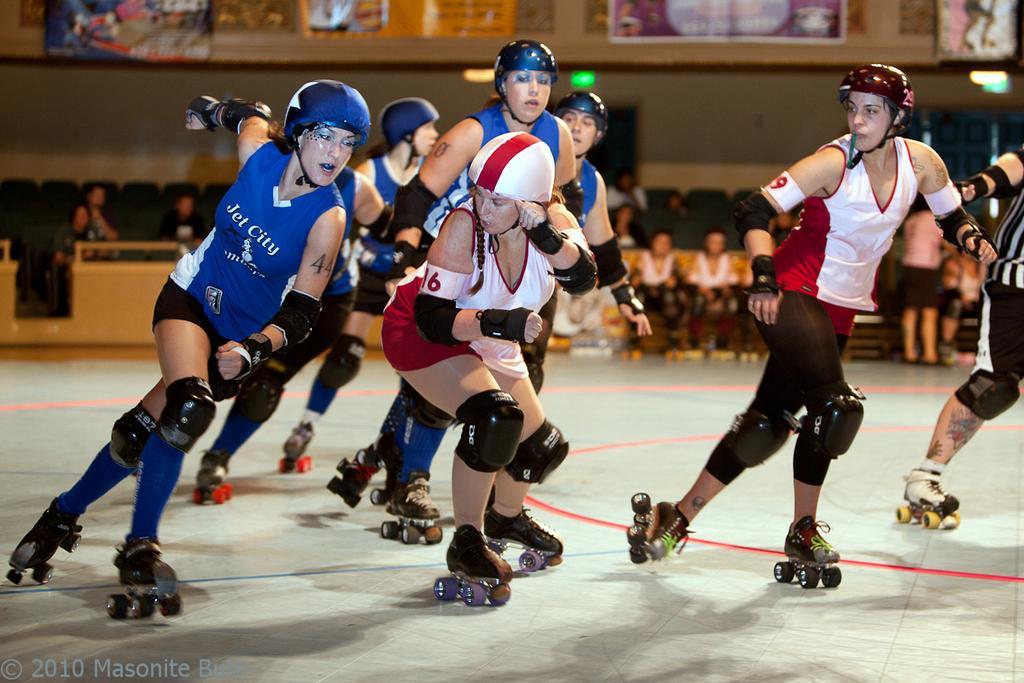In one or two sentences, can you explain what this image depicts? In this image I can see people are doing roller skating. In the background I can see people sitting on chairs. These people are wearing helmets, knee pads and roller skates. Here I can see a watermark. 